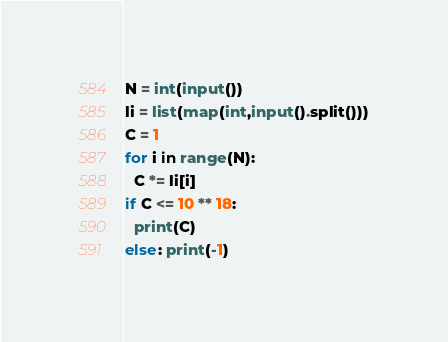Convert code to text. <code><loc_0><loc_0><loc_500><loc_500><_Python_>N = int(input())
li = list(map(int,input().split()))
C = 1
for i in range(N):
  C *= li[i]
if C <= 10 ** 18:
  print(C)
else: print(-1)</code> 